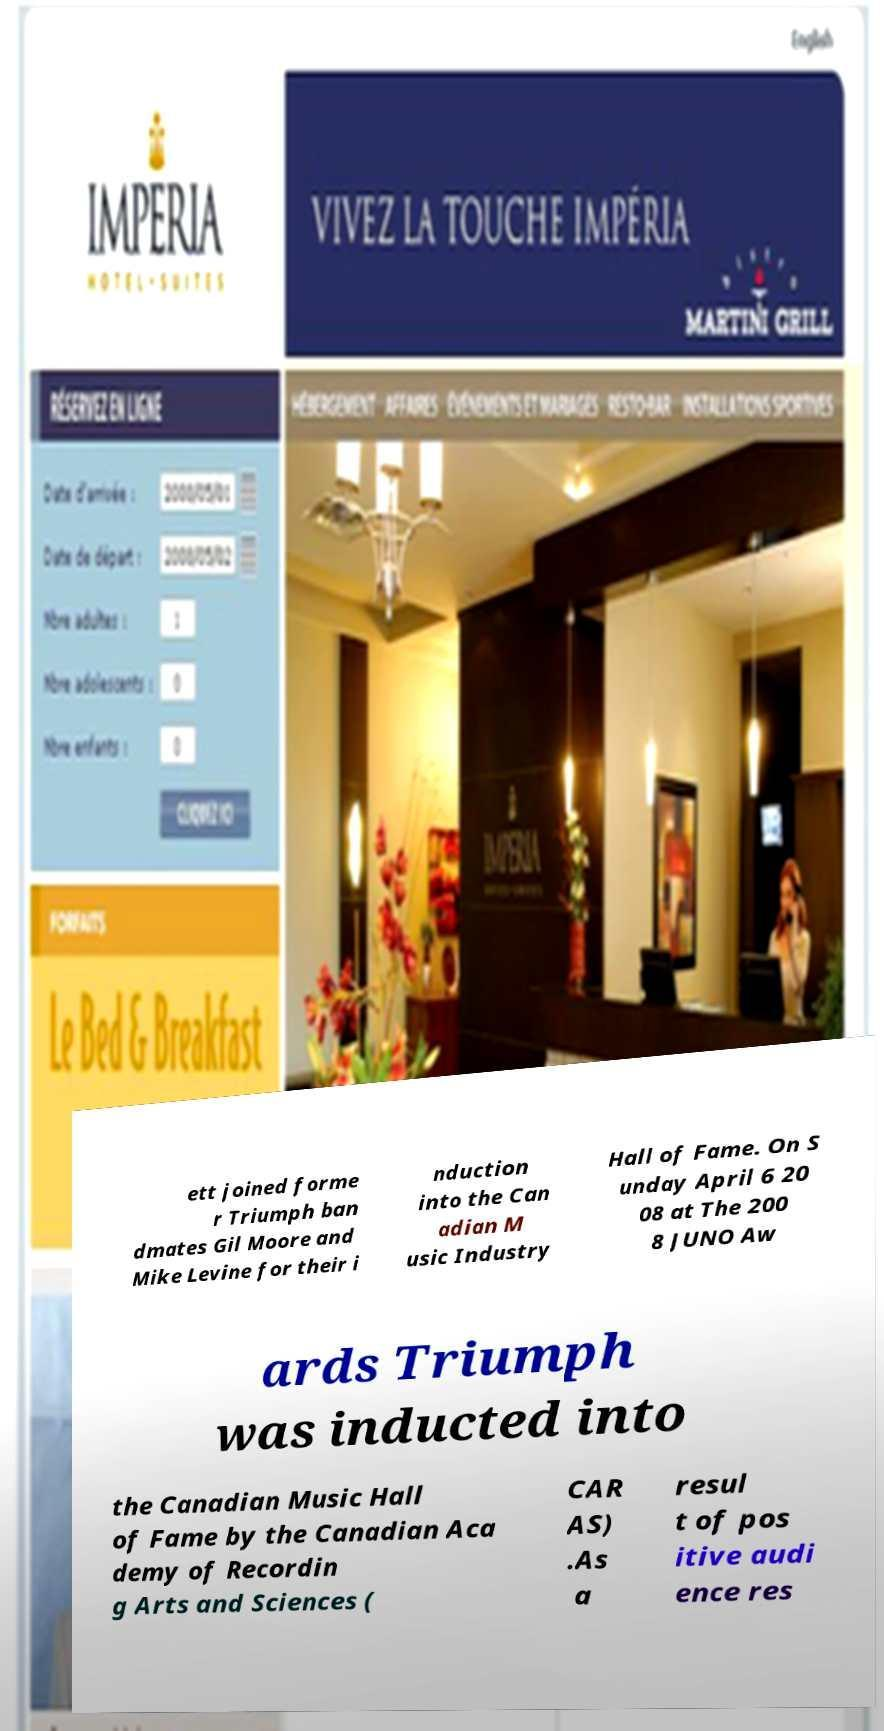What messages or text are displayed in this image? I need them in a readable, typed format. ett joined forme r Triumph ban dmates Gil Moore and Mike Levine for their i nduction into the Can adian M usic Industry Hall of Fame. On S unday April 6 20 08 at The 200 8 JUNO Aw ards Triumph was inducted into the Canadian Music Hall of Fame by the Canadian Aca demy of Recordin g Arts and Sciences ( CAR AS) .As a resul t of pos itive audi ence res 